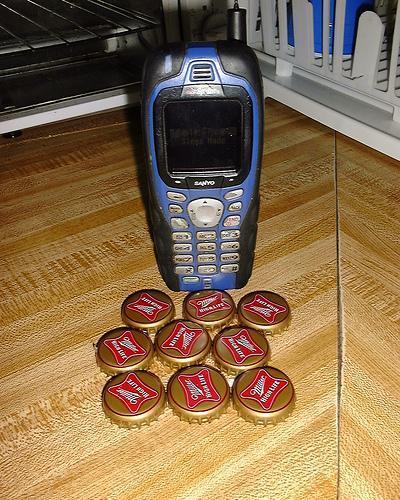How many bottle caps?
Give a very brief answer. 9. 